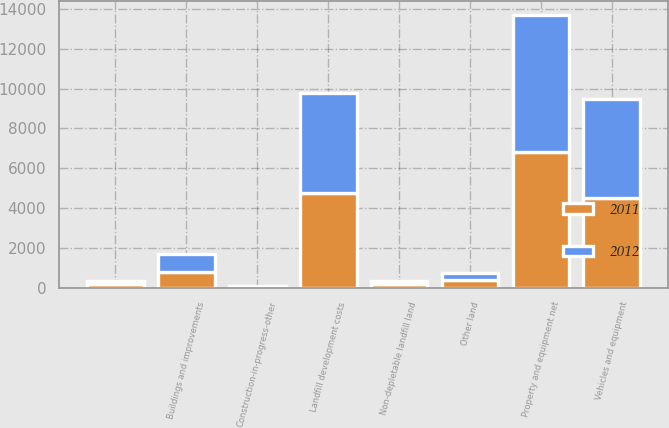Convert chart to OTSL. <chart><loc_0><loc_0><loc_500><loc_500><stacked_bar_chart><ecel><fcel>Other land<fcel>Non-depletable landfill land<fcel>Landfill development costs<fcel>Vehicles and equipment<fcel>Buildings and improvements<fcel>Unnamed: 6<fcel>Construction-in-progress-other<fcel>Property and equipment net<nl><fcel>2012<fcel>376.9<fcel>166<fcel>5018<fcel>4946.4<fcel>864.2<fcel>134.5<fcel>53.3<fcel>6910.3<nl><fcel>2011<fcel>375.1<fcel>161.8<fcel>4763.3<fcel>4515.1<fcel>802.8<fcel>187.3<fcel>47.3<fcel>6792.3<nl></chart> 